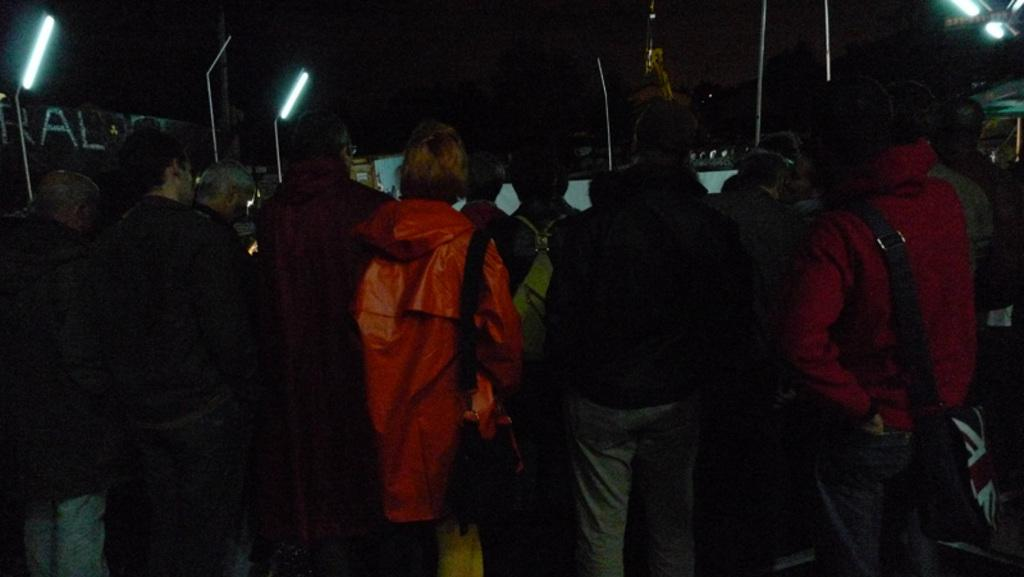What can be seen in the image involving people? There are people standing in the image. What objects are present in the image that are used for support or attachment? There are poles in the image. What can be seen in the image that provides illumination? There are lights in the image. What type of structures are visible in the image? There are sheds in the image. Are there any clams visible in the image? No, there are no clams present in the image. What type of engine can be seen powering the sheds in the image? There is no engine visible in the image, as it features people, poles, lights, and sheds, but no machinery or engines. 